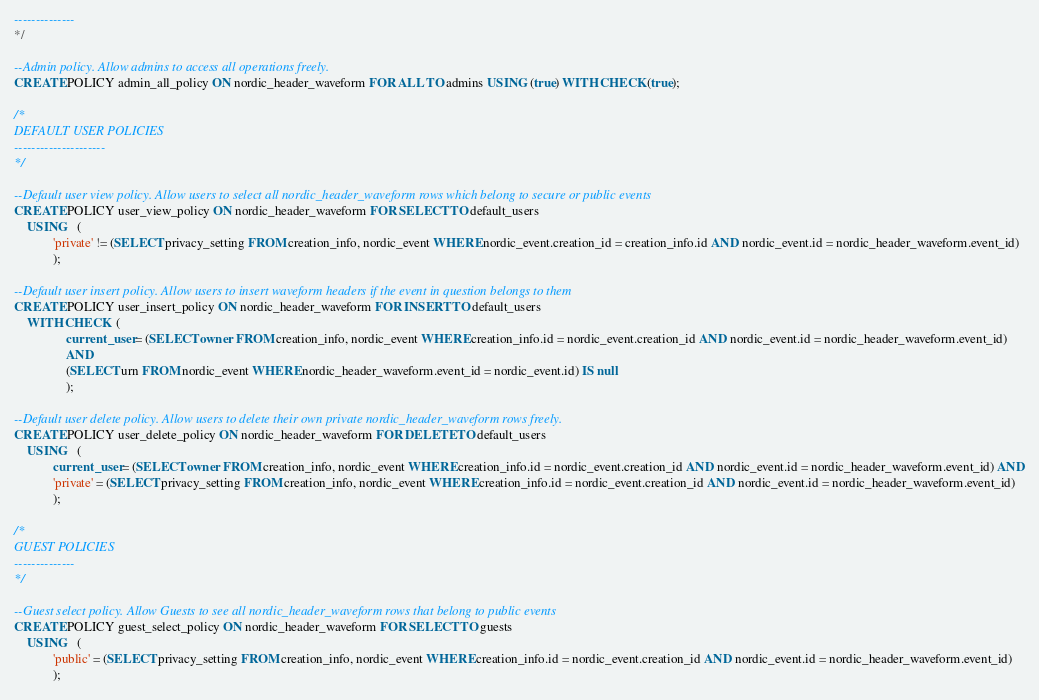<code> <loc_0><loc_0><loc_500><loc_500><_SQL_>--------------
*/

--Admin policy. Allow admins to access all operations freely.
CREATE POLICY admin_all_policy ON nordic_header_waveform FOR ALL TO admins USING (true) WITH CHECK (true);

/*
DEFAULT USER POLICIES
---------------------
*/

--Default user view policy. Allow users to select all nordic_header_waveform rows which belong to secure or public events
CREATE POLICY user_view_policy ON nordic_header_waveform FOR SELECT TO default_users 
    USING   (
            'private' != (SELECT privacy_setting FROM creation_info, nordic_event WHERE nordic_event.creation_id = creation_info.id AND nordic_event.id = nordic_header_waveform.event_id)
            );

--Default user insert policy. Allow users to insert waveform headers if the event in question belongs to them
CREATE POLICY user_insert_policy ON nordic_header_waveform FOR INSERT TO default_users 
    WITH CHECK  (
                current_user = (SELECT owner FROM creation_info, nordic_event WHERE creation_info.id = nordic_event.creation_id AND nordic_event.id = nordic_header_waveform.event_id)
                AND
                (SELECT urn FROM nordic_event WHERE nordic_header_waveform.event_id = nordic_event.id) IS null
                );

--Default user delete policy. Allow users to delete their own private nordic_header_waveform rows freely.
CREATE POLICY user_delete_policy ON nordic_header_waveform FOR DELETE TO default_users 
    USING   (
            current_user = (SELECT owner FROM creation_info, nordic_event WHERE creation_info.id = nordic_event.creation_id AND nordic_event.id = nordic_header_waveform.event_id) AND
            'private' = (SELECT privacy_setting FROM creation_info, nordic_event WHERE creation_info.id = nordic_event.creation_id AND nordic_event.id = nordic_header_waveform.event_id)
            );

/*
GUEST POLICIES
--------------
*/

--Guest select policy. Allow Guests to see all nordic_header_waveform rows that belong to public events 
CREATE POLICY guest_select_policy ON nordic_header_waveform FOR SELECT TO guests
    USING   (
            'public' = (SELECT privacy_setting FROM creation_info, nordic_event WHERE creation_info.id = nordic_event.creation_id AND nordic_event.id = nordic_header_waveform.event_id)
            );
</code> 